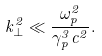<formula> <loc_0><loc_0><loc_500><loc_500>k _ { \perp } ^ { 2 } \ll \frac { \omega _ { p } ^ { 2 } } { \gamma _ { p } ^ { 3 } c ^ { 2 } } .</formula> 